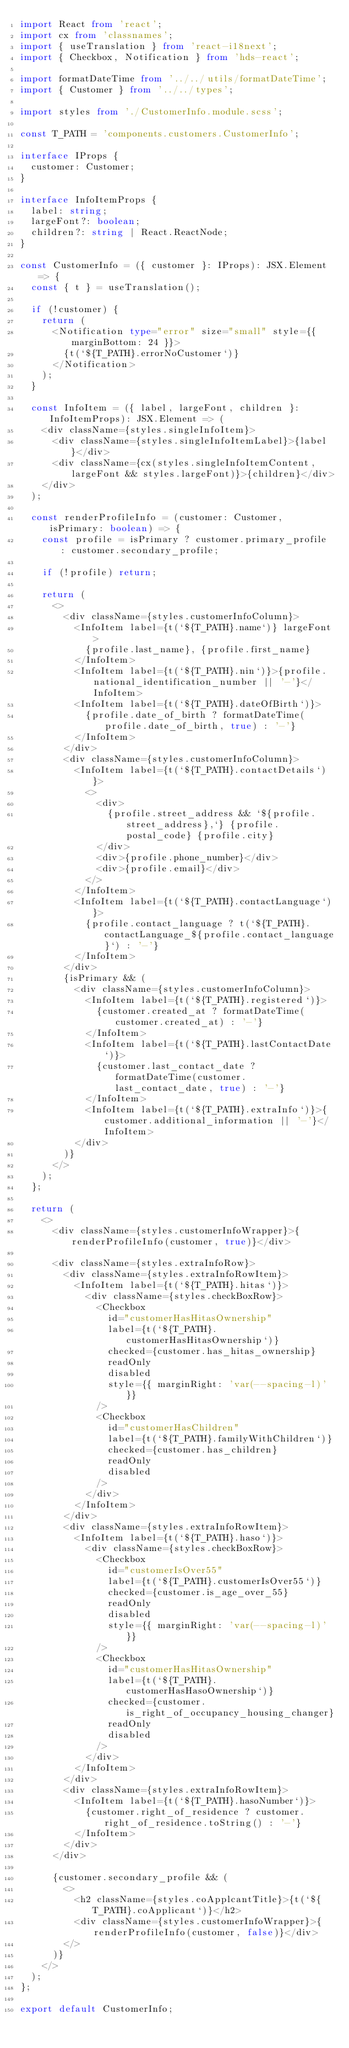Convert code to text. <code><loc_0><loc_0><loc_500><loc_500><_TypeScript_>import React from 'react';
import cx from 'classnames';
import { useTranslation } from 'react-i18next';
import { Checkbox, Notification } from 'hds-react';

import formatDateTime from '../../utils/formatDateTime';
import { Customer } from '../../types';

import styles from './CustomerInfo.module.scss';

const T_PATH = 'components.customers.CustomerInfo';

interface IProps {
  customer: Customer;
}

interface InfoItemProps {
  label: string;
  largeFont?: boolean;
  children?: string | React.ReactNode;
}

const CustomerInfo = ({ customer }: IProps): JSX.Element => {
  const { t } = useTranslation();

  if (!customer) {
    return (
      <Notification type="error" size="small" style={{ marginBottom: 24 }}>
        {t(`${T_PATH}.errorNoCustomer`)}
      </Notification>
    );
  }

  const InfoItem = ({ label, largeFont, children }: InfoItemProps): JSX.Element => (
    <div className={styles.singleInfoItem}>
      <div className={styles.singleInfoItemLabel}>{label}</div>
      <div className={cx(styles.singleInfoItemContent, largeFont && styles.largeFont)}>{children}</div>
    </div>
  );

  const renderProfileInfo = (customer: Customer, isPrimary: boolean) => {
    const profile = isPrimary ? customer.primary_profile : customer.secondary_profile;

    if (!profile) return;

    return (
      <>
        <div className={styles.customerInfoColumn}>
          <InfoItem label={t(`${T_PATH}.name`)} largeFont>
            {profile.last_name}, {profile.first_name}
          </InfoItem>
          <InfoItem label={t(`${T_PATH}.nin`)}>{profile.national_identification_number || '-'}</InfoItem>
          <InfoItem label={t(`${T_PATH}.dateOfBirth`)}>
            {profile.date_of_birth ? formatDateTime(profile.date_of_birth, true) : '-'}
          </InfoItem>
        </div>
        <div className={styles.customerInfoColumn}>
          <InfoItem label={t(`${T_PATH}.contactDetails`)}>
            <>
              <div>
                {profile.street_address && `${profile.street_address},`} {profile.postal_code} {profile.city}
              </div>
              <div>{profile.phone_number}</div>
              <div>{profile.email}</div>
            </>
          </InfoItem>
          <InfoItem label={t(`${T_PATH}.contactLanguage`)}>
            {profile.contact_language ? t(`${T_PATH}.contactLanguage_${profile.contact_language}`) : '-'}
          </InfoItem>
        </div>
        {isPrimary && (
          <div className={styles.customerInfoColumn}>
            <InfoItem label={t(`${T_PATH}.registered`)}>
              {customer.created_at ? formatDateTime(customer.created_at) : '-'}
            </InfoItem>
            <InfoItem label={t(`${T_PATH}.lastContactDate`)}>
              {customer.last_contact_date ? formatDateTime(customer.last_contact_date, true) : '-'}
            </InfoItem>
            <InfoItem label={t(`${T_PATH}.extraInfo`)}>{customer.additional_information || '-'}</InfoItem>
          </div>
        )}
      </>
    );
  };

  return (
    <>
      <div className={styles.customerInfoWrapper}>{renderProfileInfo(customer, true)}</div>

      <div className={styles.extraInfoRow}>
        <div className={styles.extraInfoRowItem}>
          <InfoItem label={t(`${T_PATH}.hitas`)}>
            <div className={styles.checkBoxRow}>
              <Checkbox
                id="customerHasHitasOwnership"
                label={t(`${T_PATH}.customerHasHitasOwnership`)}
                checked={customer.has_hitas_ownership}
                readOnly
                disabled
                style={{ marginRight: 'var(--spacing-l)' }}
              />
              <Checkbox
                id="customerHasChildren"
                label={t(`${T_PATH}.familyWithChildren`)}
                checked={customer.has_children}
                readOnly
                disabled
              />
            </div>
          </InfoItem>
        </div>
        <div className={styles.extraInfoRowItem}>
          <InfoItem label={t(`${T_PATH}.haso`)}>
            <div className={styles.checkBoxRow}>
              <Checkbox
                id="customerIsOver55"
                label={t(`${T_PATH}.customerIsOver55`)}
                checked={customer.is_age_over_55}
                readOnly
                disabled
                style={{ marginRight: 'var(--spacing-l)' }}
              />
              <Checkbox
                id="customerHasHitasOwnership"
                label={t(`${T_PATH}.customerHasHasoOwnership`)}
                checked={customer.is_right_of_occupancy_housing_changer}
                readOnly
                disabled
              />
            </div>
          </InfoItem>
        </div>
        <div className={styles.extraInfoRowItem}>
          <InfoItem label={t(`${T_PATH}.hasoNumber`)}>
            {customer.right_of_residence ? customer.right_of_residence.toString() : '-'}
          </InfoItem>
        </div>
      </div>

      {customer.secondary_profile && (
        <>
          <h2 className={styles.coApplcantTitle}>{t(`${T_PATH}.coApplicant`)}</h2>
          <div className={styles.customerInfoWrapper}>{renderProfileInfo(customer, false)}</div>
        </>
      )}
    </>
  );
};

export default CustomerInfo;
</code> 